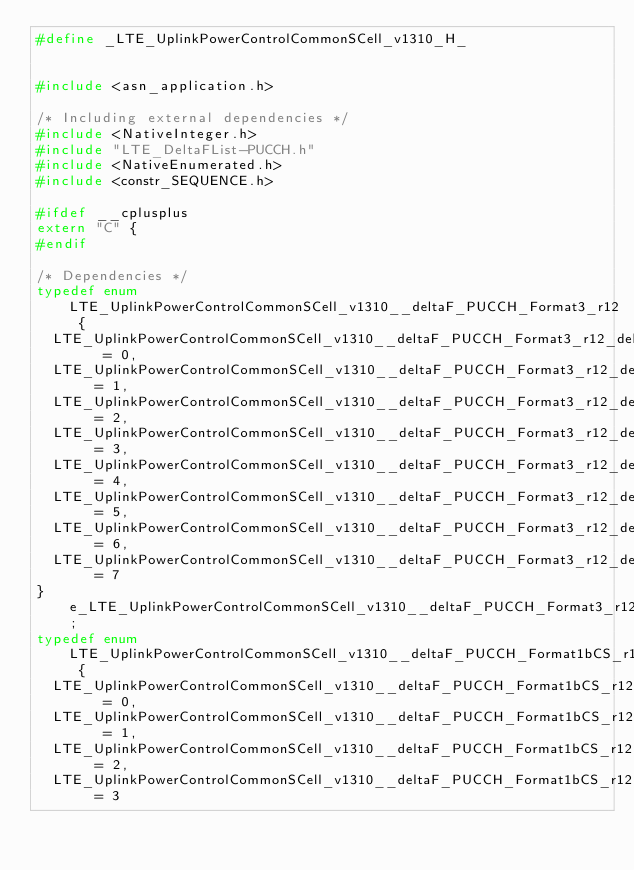<code> <loc_0><loc_0><loc_500><loc_500><_C_>#define	_LTE_UplinkPowerControlCommonSCell_v1310_H_


#include <asn_application.h>

/* Including external dependencies */
#include <NativeInteger.h>
#include "LTE_DeltaFList-PUCCH.h"
#include <NativeEnumerated.h>
#include <constr_SEQUENCE.h>

#ifdef __cplusplus
extern "C" {
#endif

/* Dependencies */
typedef enum LTE_UplinkPowerControlCommonSCell_v1310__deltaF_PUCCH_Format3_r12 {
	LTE_UplinkPowerControlCommonSCell_v1310__deltaF_PUCCH_Format3_r12_deltaF_1	= 0,
	LTE_UplinkPowerControlCommonSCell_v1310__deltaF_PUCCH_Format3_r12_deltaF0	= 1,
	LTE_UplinkPowerControlCommonSCell_v1310__deltaF_PUCCH_Format3_r12_deltaF1	= 2,
	LTE_UplinkPowerControlCommonSCell_v1310__deltaF_PUCCH_Format3_r12_deltaF2	= 3,
	LTE_UplinkPowerControlCommonSCell_v1310__deltaF_PUCCH_Format3_r12_deltaF3	= 4,
	LTE_UplinkPowerControlCommonSCell_v1310__deltaF_PUCCH_Format3_r12_deltaF4	= 5,
	LTE_UplinkPowerControlCommonSCell_v1310__deltaF_PUCCH_Format3_r12_deltaF5	= 6,
	LTE_UplinkPowerControlCommonSCell_v1310__deltaF_PUCCH_Format3_r12_deltaF6	= 7
} e_LTE_UplinkPowerControlCommonSCell_v1310__deltaF_PUCCH_Format3_r12;
typedef enum LTE_UplinkPowerControlCommonSCell_v1310__deltaF_PUCCH_Format1bCS_r12 {
	LTE_UplinkPowerControlCommonSCell_v1310__deltaF_PUCCH_Format1bCS_r12_deltaF1	= 0,
	LTE_UplinkPowerControlCommonSCell_v1310__deltaF_PUCCH_Format1bCS_r12_deltaF2	= 1,
	LTE_UplinkPowerControlCommonSCell_v1310__deltaF_PUCCH_Format1bCS_r12_spare2	= 2,
	LTE_UplinkPowerControlCommonSCell_v1310__deltaF_PUCCH_Format1bCS_r12_spare1	= 3</code> 